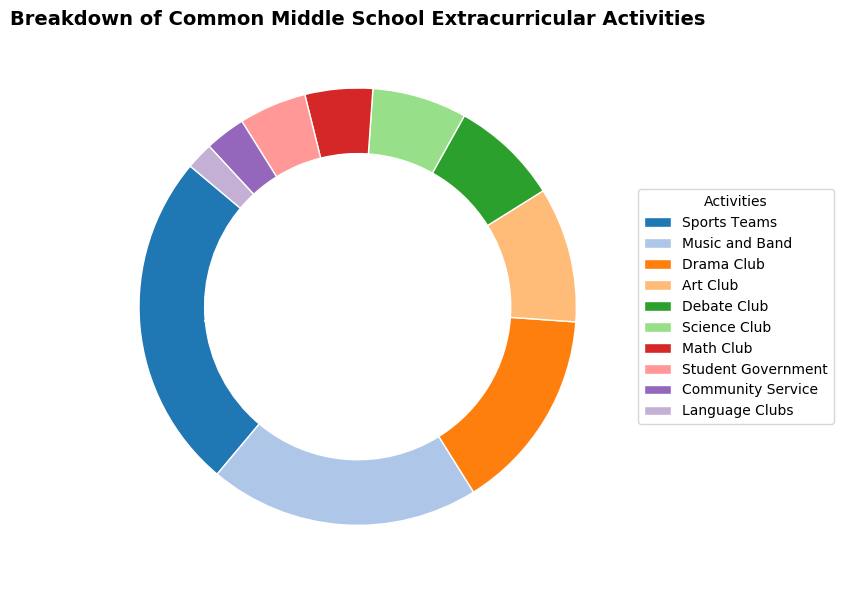What's the total percentage of students participating in Debate Club and Science Club combined? To find the total percentage, sum the percentages of the Debate Club and Science Club. Debate Club is 8%, Science Club is 7%. Their combined percentage is 8% + 7% = 15%.
Answer: 15% Which activity has the second-largest percentage? To find the second-largest percentage, look at the given percentages in descending order. Sports Teams has the largest percentage (25%), followed by Music and Band (20%). Therefore, Music and Band has the second-largest percentage.
Answer: Music and Band Does Student Government or Math Club have a higher percentage? Compare the percentages of Student Government and Math Club. Both have the same percentage of 5%.
Answer: They are equal What is the least popular activity and its percentage? Identify the activity with the smallest percentage from the list. Language Clubs is the least popular with a percentage of 2%.
Answer: Language Clubs, 2% What's the difference in percentage between Sports Teams and Drama Club? Subtract the percentage of Drama Club from the percentage of Sports Teams. Sports Teams is 25%, Drama Club is 15%. The difference is 25% - 15% = 10%.
Answer: 10% How many activities have a percentage of 10% or higher? Count the activities with percentages that are 10% or higher. Sports Teams (25%), Music and Band (20%), Drama Club (15%), and Art Club (10%). There are 4 such activities.
Answer: 4 What is the combined percentage of all clubs related to art and performance (Art Club, Drama Club, Music and Band)? Sum the percentages of Art Club, Drama Club, and Music and Band. Art Club is 10%, Drama Club is 15%, and Music and Band is 20%. Their combined percentage is 10% + 15% + 20% = 45%.
Answer: 45% Is the percentage of students in Debate Club greater than the percentage of students in Science Club or Math Club? Compare the percentage of Debate Club (8%) with Science Club (7%) and Math Club (5%). Debate Club has a higher percentage than both.
Answer: Yes What is the average percentage of students participating in Language Clubs, Community Service, and Student Government? To find the average, sum the percentages of Language Clubs, Community Service, and Student Government, then divide by the number of activities. Language Clubs is 2%, Community Service is 3%, Student Government is 5%. Sum is 2% + 3% + 5% = 10%. Average is 10% / 3 ≈ 3.33%.
Answer: 3.33% 